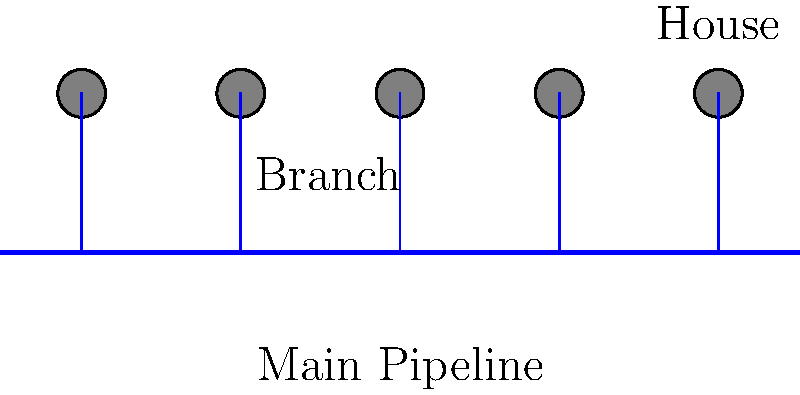In designing an efficient water distribution system for a low-income community, what is the primary advantage of using a branched network layout as shown in the diagram? To understand the advantage of a branched network layout for a low-income community's water distribution system, let's consider the following points:

1. Cost-effectiveness: A branched network uses less piping material compared to a looped system, reducing initial installation costs.

2. Simplicity: The layout is straightforward, making it easier to construct and maintain, which is crucial for communities with limited resources.

3. Pressure management: Water pressure can be more easily controlled in a branched system, as there's a single flow path to each endpoint.

4. Demand allocation: It's easier to calculate and meet the water demand for each branch, ensuring fair distribution.

5. Leak detection: Any issues in the system can be more readily identified and isolated due to the simple layout.

6. Expandability: New branches can be added to the main pipeline as the community grows, without disrupting the entire system.

7. Water quality control: With a single flow path, it's easier to maintain consistent water quality throughout the system.

The primary advantage that encompasses many of these points is the overall cost-effectiveness of the system, both in terms of initial installation and long-term maintenance. This is particularly important for low-income communities where resources are limited.
Answer: Cost-effectiveness 